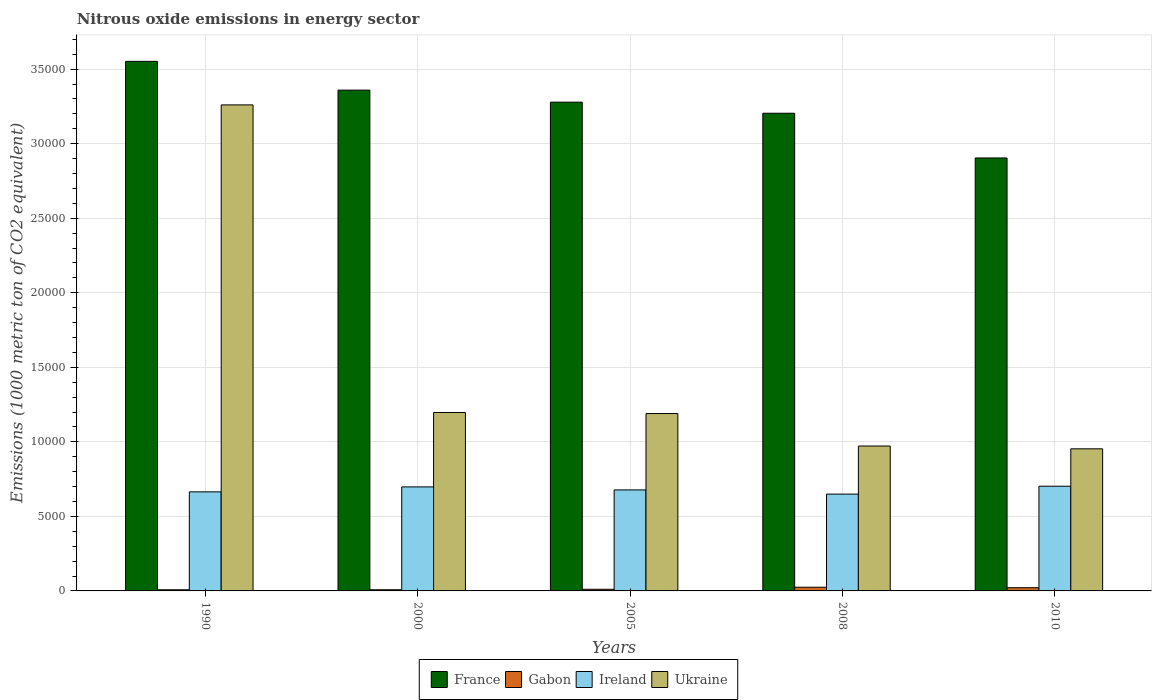How many groups of bars are there?
Give a very brief answer. 5. How many bars are there on the 5th tick from the right?
Provide a short and direct response. 4. In how many cases, is the number of bars for a given year not equal to the number of legend labels?
Give a very brief answer. 0. What is the amount of nitrous oxide emitted in Ireland in 2005?
Offer a terse response. 6774.5. Across all years, what is the maximum amount of nitrous oxide emitted in France?
Ensure brevity in your answer.  3.55e+04. Across all years, what is the minimum amount of nitrous oxide emitted in France?
Offer a terse response. 2.90e+04. In which year was the amount of nitrous oxide emitted in Gabon maximum?
Offer a very short reply. 2008. What is the total amount of nitrous oxide emitted in Ireland in the graph?
Your answer should be very brief. 3.39e+04. What is the difference between the amount of nitrous oxide emitted in Gabon in 2005 and that in 2010?
Your answer should be compact. -104.5. What is the difference between the amount of nitrous oxide emitted in Ukraine in 2000 and the amount of nitrous oxide emitted in Gabon in 1990?
Your answer should be very brief. 1.19e+04. What is the average amount of nitrous oxide emitted in Ireland per year?
Provide a short and direct response. 6782.7. In the year 2005, what is the difference between the amount of nitrous oxide emitted in Gabon and amount of nitrous oxide emitted in France?
Provide a succinct answer. -3.27e+04. In how many years, is the amount of nitrous oxide emitted in Gabon greater than 22000 1000 metric ton?
Offer a very short reply. 0. What is the ratio of the amount of nitrous oxide emitted in Ireland in 2000 to that in 2005?
Your response must be concise. 1.03. Is the amount of nitrous oxide emitted in Ireland in 2008 less than that in 2010?
Give a very brief answer. Yes. What is the difference between the highest and the second highest amount of nitrous oxide emitted in Ireland?
Your answer should be compact. 45.2. What is the difference between the highest and the lowest amount of nitrous oxide emitted in Ukraine?
Offer a terse response. 2.31e+04. What does the 2nd bar from the left in 2005 represents?
Keep it short and to the point. Gabon. What does the 3rd bar from the right in 2008 represents?
Keep it short and to the point. Gabon. Is it the case that in every year, the sum of the amount of nitrous oxide emitted in Gabon and amount of nitrous oxide emitted in France is greater than the amount of nitrous oxide emitted in Ukraine?
Provide a short and direct response. Yes. What is the difference between two consecutive major ticks on the Y-axis?
Ensure brevity in your answer.  5000. Are the values on the major ticks of Y-axis written in scientific E-notation?
Give a very brief answer. No. Does the graph contain grids?
Keep it short and to the point. Yes. How many legend labels are there?
Your answer should be very brief. 4. What is the title of the graph?
Your answer should be very brief. Nitrous oxide emissions in energy sector. Does "United States" appear as one of the legend labels in the graph?
Give a very brief answer. No. What is the label or title of the Y-axis?
Your response must be concise. Emissions (1000 metric ton of CO2 equivalent). What is the Emissions (1000 metric ton of CO2 equivalent) of France in 1990?
Ensure brevity in your answer.  3.55e+04. What is the Emissions (1000 metric ton of CO2 equivalent) of Gabon in 1990?
Make the answer very short. 77.4. What is the Emissions (1000 metric ton of CO2 equivalent) in Ireland in 1990?
Give a very brief answer. 6644.8. What is the Emissions (1000 metric ton of CO2 equivalent) of Ukraine in 1990?
Give a very brief answer. 3.26e+04. What is the Emissions (1000 metric ton of CO2 equivalent) in France in 2000?
Provide a short and direct response. 3.36e+04. What is the Emissions (1000 metric ton of CO2 equivalent) in Gabon in 2000?
Your response must be concise. 78.3. What is the Emissions (1000 metric ton of CO2 equivalent) in Ireland in 2000?
Your answer should be very brief. 6977.3. What is the Emissions (1000 metric ton of CO2 equivalent) in Ukraine in 2000?
Keep it short and to the point. 1.20e+04. What is the Emissions (1000 metric ton of CO2 equivalent) in France in 2005?
Ensure brevity in your answer.  3.28e+04. What is the Emissions (1000 metric ton of CO2 equivalent) in Gabon in 2005?
Your response must be concise. 110.8. What is the Emissions (1000 metric ton of CO2 equivalent) in Ireland in 2005?
Offer a very short reply. 6774.5. What is the Emissions (1000 metric ton of CO2 equivalent) of Ukraine in 2005?
Ensure brevity in your answer.  1.19e+04. What is the Emissions (1000 metric ton of CO2 equivalent) of France in 2008?
Ensure brevity in your answer.  3.20e+04. What is the Emissions (1000 metric ton of CO2 equivalent) in Gabon in 2008?
Provide a succinct answer. 248.2. What is the Emissions (1000 metric ton of CO2 equivalent) in Ireland in 2008?
Your answer should be very brief. 6494.4. What is the Emissions (1000 metric ton of CO2 equivalent) in Ukraine in 2008?
Ensure brevity in your answer.  9719.1. What is the Emissions (1000 metric ton of CO2 equivalent) in France in 2010?
Provide a succinct answer. 2.90e+04. What is the Emissions (1000 metric ton of CO2 equivalent) in Gabon in 2010?
Provide a short and direct response. 215.3. What is the Emissions (1000 metric ton of CO2 equivalent) in Ireland in 2010?
Your answer should be very brief. 7022.5. What is the Emissions (1000 metric ton of CO2 equivalent) in Ukraine in 2010?
Your answer should be very brief. 9531.4. Across all years, what is the maximum Emissions (1000 metric ton of CO2 equivalent) of France?
Make the answer very short. 3.55e+04. Across all years, what is the maximum Emissions (1000 metric ton of CO2 equivalent) in Gabon?
Offer a terse response. 248.2. Across all years, what is the maximum Emissions (1000 metric ton of CO2 equivalent) in Ireland?
Your answer should be compact. 7022.5. Across all years, what is the maximum Emissions (1000 metric ton of CO2 equivalent) of Ukraine?
Your response must be concise. 3.26e+04. Across all years, what is the minimum Emissions (1000 metric ton of CO2 equivalent) in France?
Your response must be concise. 2.90e+04. Across all years, what is the minimum Emissions (1000 metric ton of CO2 equivalent) of Gabon?
Your response must be concise. 77.4. Across all years, what is the minimum Emissions (1000 metric ton of CO2 equivalent) of Ireland?
Provide a succinct answer. 6494.4. Across all years, what is the minimum Emissions (1000 metric ton of CO2 equivalent) in Ukraine?
Provide a short and direct response. 9531.4. What is the total Emissions (1000 metric ton of CO2 equivalent) in France in the graph?
Your response must be concise. 1.63e+05. What is the total Emissions (1000 metric ton of CO2 equivalent) of Gabon in the graph?
Keep it short and to the point. 730. What is the total Emissions (1000 metric ton of CO2 equivalent) of Ireland in the graph?
Provide a short and direct response. 3.39e+04. What is the total Emissions (1000 metric ton of CO2 equivalent) of Ukraine in the graph?
Keep it short and to the point. 7.57e+04. What is the difference between the Emissions (1000 metric ton of CO2 equivalent) in France in 1990 and that in 2000?
Provide a short and direct response. 1930.3. What is the difference between the Emissions (1000 metric ton of CO2 equivalent) in Gabon in 1990 and that in 2000?
Offer a terse response. -0.9. What is the difference between the Emissions (1000 metric ton of CO2 equivalent) of Ireland in 1990 and that in 2000?
Your answer should be very brief. -332.5. What is the difference between the Emissions (1000 metric ton of CO2 equivalent) of Ukraine in 1990 and that in 2000?
Give a very brief answer. 2.06e+04. What is the difference between the Emissions (1000 metric ton of CO2 equivalent) in France in 1990 and that in 2005?
Provide a short and direct response. 2736.8. What is the difference between the Emissions (1000 metric ton of CO2 equivalent) of Gabon in 1990 and that in 2005?
Keep it short and to the point. -33.4. What is the difference between the Emissions (1000 metric ton of CO2 equivalent) of Ireland in 1990 and that in 2005?
Make the answer very short. -129.7. What is the difference between the Emissions (1000 metric ton of CO2 equivalent) of Ukraine in 1990 and that in 2005?
Your response must be concise. 2.07e+04. What is the difference between the Emissions (1000 metric ton of CO2 equivalent) of France in 1990 and that in 2008?
Your answer should be compact. 3480.3. What is the difference between the Emissions (1000 metric ton of CO2 equivalent) of Gabon in 1990 and that in 2008?
Offer a very short reply. -170.8. What is the difference between the Emissions (1000 metric ton of CO2 equivalent) in Ireland in 1990 and that in 2008?
Your response must be concise. 150.4. What is the difference between the Emissions (1000 metric ton of CO2 equivalent) of Ukraine in 1990 and that in 2008?
Provide a short and direct response. 2.29e+04. What is the difference between the Emissions (1000 metric ton of CO2 equivalent) in France in 1990 and that in 2010?
Provide a succinct answer. 6479.5. What is the difference between the Emissions (1000 metric ton of CO2 equivalent) in Gabon in 1990 and that in 2010?
Keep it short and to the point. -137.9. What is the difference between the Emissions (1000 metric ton of CO2 equivalent) in Ireland in 1990 and that in 2010?
Ensure brevity in your answer.  -377.7. What is the difference between the Emissions (1000 metric ton of CO2 equivalent) in Ukraine in 1990 and that in 2010?
Provide a short and direct response. 2.31e+04. What is the difference between the Emissions (1000 metric ton of CO2 equivalent) in France in 2000 and that in 2005?
Ensure brevity in your answer.  806.5. What is the difference between the Emissions (1000 metric ton of CO2 equivalent) of Gabon in 2000 and that in 2005?
Your answer should be very brief. -32.5. What is the difference between the Emissions (1000 metric ton of CO2 equivalent) in Ireland in 2000 and that in 2005?
Make the answer very short. 202.8. What is the difference between the Emissions (1000 metric ton of CO2 equivalent) of Ukraine in 2000 and that in 2005?
Provide a succinct answer. 70.4. What is the difference between the Emissions (1000 metric ton of CO2 equivalent) of France in 2000 and that in 2008?
Keep it short and to the point. 1550. What is the difference between the Emissions (1000 metric ton of CO2 equivalent) of Gabon in 2000 and that in 2008?
Offer a very short reply. -169.9. What is the difference between the Emissions (1000 metric ton of CO2 equivalent) in Ireland in 2000 and that in 2008?
Ensure brevity in your answer.  482.9. What is the difference between the Emissions (1000 metric ton of CO2 equivalent) of Ukraine in 2000 and that in 2008?
Provide a succinct answer. 2248.8. What is the difference between the Emissions (1000 metric ton of CO2 equivalent) of France in 2000 and that in 2010?
Provide a succinct answer. 4549.2. What is the difference between the Emissions (1000 metric ton of CO2 equivalent) in Gabon in 2000 and that in 2010?
Provide a short and direct response. -137. What is the difference between the Emissions (1000 metric ton of CO2 equivalent) of Ireland in 2000 and that in 2010?
Your answer should be very brief. -45.2. What is the difference between the Emissions (1000 metric ton of CO2 equivalent) in Ukraine in 2000 and that in 2010?
Your answer should be very brief. 2436.5. What is the difference between the Emissions (1000 metric ton of CO2 equivalent) of France in 2005 and that in 2008?
Provide a short and direct response. 743.5. What is the difference between the Emissions (1000 metric ton of CO2 equivalent) in Gabon in 2005 and that in 2008?
Ensure brevity in your answer.  -137.4. What is the difference between the Emissions (1000 metric ton of CO2 equivalent) in Ireland in 2005 and that in 2008?
Provide a short and direct response. 280.1. What is the difference between the Emissions (1000 metric ton of CO2 equivalent) of Ukraine in 2005 and that in 2008?
Your answer should be compact. 2178.4. What is the difference between the Emissions (1000 metric ton of CO2 equivalent) in France in 2005 and that in 2010?
Keep it short and to the point. 3742.7. What is the difference between the Emissions (1000 metric ton of CO2 equivalent) of Gabon in 2005 and that in 2010?
Provide a short and direct response. -104.5. What is the difference between the Emissions (1000 metric ton of CO2 equivalent) in Ireland in 2005 and that in 2010?
Provide a succinct answer. -248. What is the difference between the Emissions (1000 metric ton of CO2 equivalent) of Ukraine in 2005 and that in 2010?
Provide a succinct answer. 2366.1. What is the difference between the Emissions (1000 metric ton of CO2 equivalent) of France in 2008 and that in 2010?
Make the answer very short. 2999.2. What is the difference between the Emissions (1000 metric ton of CO2 equivalent) in Gabon in 2008 and that in 2010?
Make the answer very short. 32.9. What is the difference between the Emissions (1000 metric ton of CO2 equivalent) in Ireland in 2008 and that in 2010?
Your answer should be very brief. -528.1. What is the difference between the Emissions (1000 metric ton of CO2 equivalent) of Ukraine in 2008 and that in 2010?
Your answer should be compact. 187.7. What is the difference between the Emissions (1000 metric ton of CO2 equivalent) of France in 1990 and the Emissions (1000 metric ton of CO2 equivalent) of Gabon in 2000?
Ensure brevity in your answer.  3.54e+04. What is the difference between the Emissions (1000 metric ton of CO2 equivalent) of France in 1990 and the Emissions (1000 metric ton of CO2 equivalent) of Ireland in 2000?
Keep it short and to the point. 2.85e+04. What is the difference between the Emissions (1000 metric ton of CO2 equivalent) of France in 1990 and the Emissions (1000 metric ton of CO2 equivalent) of Ukraine in 2000?
Provide a succinct answer. 2.36e+04. What is the difference between the Emissions (1000 metric ton of CO2 equivalent) in Gabon in 1990 and the Emissions (1000 metric ton of CO2 equivalent) in Ireland in 2000?
Ensure brevity in your answer.  -6899.9. What is the difference between the Emissions (1000 metric ton of CO2 equivalent) of Gabon in 1990 and the Emissions (1000 metric ton of CO2 equivalent) of Ukraine in 2000?
Your answer should be very brief. -1.19e+04. What is the difference between the Emissions (1000 metric ton of CO2 equivalent) of Ireland in 1990 and the Emissions (1000 metric ton of CO2 equivalent) of Ukraine in 2000?
Give a very brief answer. -5323.1. What is the difference between the Emissions (1000 metric ton of CO2 equivalent) of France in 1990 and the Emissions (1000 metric ton of CO2 equivalent) of Gabon in 2005?
Keep it short and to the point. 3.54e+04. What is the difference between the Emissions (1000 metric ton of CO2 equivalent) in France in 1990 and the Emissions (1000 metric ton of CO2 equivalent) in Ireland in 2005?
Your answer should be very brief. 2.87e+04. What is the difference between the Emissions (1000 metric ton of CO2 equivalent) in France in 1990 and the Emissions (1000 metric ton of CO2 equivalent) in Ukraine in 2005?
Provide a short and direct response. 2.36e+04. What is the difference between the Emissions (1000 metric ton of CO2 equivalent) in Gabon in 1990 and the Emissions (1000 metric ton of CO2 equivalent) in Ireland in 2005?
Make the answer very short. -6697.1. What is the difference between the Emissions (1000 metric ton of CO2 equivalent) of Gabon in 1990 and the Emissions (1000 metric ton of CO2 equivalent) of Ukraine in 2005?
Offer a terse response. -1.18e+04. What is the difference between the Emissions (1000 metric ton of CO2 equivalent) in Ireland in 1990 and the Emissions (1000 metric ton of CO2 equivalent) in Ukraine in 2005?
Offer a very short reply. -5252.7. What is the difference between the Emissions (1000 metric ton of CO2 equivalent) of France in 1990 and the Emissions (1000 metric ton of CO2 equivalent) of Gabon in 2008?
Your response must be concise. 3.53e+04. What is the difference between the Emissions (1000 metric ton of CO2 equivalent) in France in 1990 and the Emissions (1000 metric ton of CO2 equivalent) in Ireland in 2008?
Ensure brevity in your answer.  2.90e+04. What is the difference between the Emissions (1000 metric ton of CO2 equivalent) in France in 1990 and the Emissions (1000 metric ton of CO2 equivalent) in Ukraine in 2008?
Offer a very short reply. 2.58e+04. What is the difference between the Emissions (1000 metric ton of CO2 equivalent) of Gabon in 1990 and the Emissions (1000 metric ton of CO2 equivalent) of Ireland in 2008?
Keep it short and to the point. -6417. What is the difference between the Emissions (1000 metric ton of CO2 equivalent) in Gabon in 1990 and the Emissions (1000 metric ton of CO2 equivalent) in Ukraine in 2008?
Your answer should be very brief. -9641.7. What is the difference between the Emissions (1000 metric ton of CO2 equivalent) of Ireland in 1990 and the Emissions (1000 metric ton of CO2 equivalent) of Ukraine in 2008?
Keep it short and to the point. -3074.3. What is the difference between the Emissions (1000 metric ton of CO2 equivalent) of France in 1990 and the Emissions (1000 metric ton of CO2 equivalent) of Gabon in 2010?
Make the answer very short. 3.53e+04. What is the difference between the Emissions (1000 metric ton of CO2 equivalent) in France in 1990 and the Emissions (1000 metric ton of CO2 equivalent) in Ireland in 2010?
Your answer should be compact. 2.85e+04. What is the difference between the Emissions (1000 metric ton of CO2 equivalent) of France in 1990 and the Emissions (1000 metric ton of CO2 equivalent) of Ukraine in 2010?
Offer a very short reply. 2.60e+04. What is the difference between the Emissions (1000 metric ton of CO2 equivalent) of Gabon in 1990 and the Emissions (1000 metric ton of CO2 equivalent) of Ireland in 2010?
Provide a succinct answer. -6945.1. What is the difference between the Emissions (1000 metric ton of CO2 equivalent) of Gabon in 1990 and the Emissions (1000 metric ton of CO2 equivalent) of Ukraine in 2010?
Your answer should be very brief. -9454. What is the difference between the Emissions (1000 metric ton of CO2 equivalent) of Ireland in 1990 and the Emissions (1000 metric ton of CO2 equivalent) of Ukraine in 2010?
Offer a terse response. -2886.6. What is the difference between the Emissions (1000 metric ton of CO2 equivalent) of France in 2000 and the Emissions (1000 metric ton of CO2 equivalent) of Gabon in 2005?
Offer a terse response. 3.35e+04. What is the difference between the Emissions (1000 metric ton of CO2 equivalent) in France in 2000 and the Emissions (1000 metric ton of CO2 equivalent) in Ireland in 2005?
Offer a terse response. 2.68e+04. What is the difference between the Emissions (1000 metric ton of CO2 equivalent) of France in 2000 and the Emissions (1000 metric ton of CO2 equivalent) of Ukraine in 2005?
Your response must be concise. 2.17e+04. What is the difference between the Emissions (1000 metric ton of CO2 equivalent) of Gabon in 2000 and the Emissions (1000 metric ton of CO2 equivalent) of Ireland in 2005?
Your answer should be very brief. -6696.2. What is the difference between the Emissions (1000 metric ton of CO2 equivalent) in Gabon in 2000 and the Emissions (1000 metric ton of CO2 equivalent) in Ukraine in 2005?
Your answer should be compact. -1.18e+04. What is the difference between the Emissions (1000 metric ton of CO2 equivalent) in Ireland in 2000 and the Emissions (1000 metric ton of CO2 equivalent) in Ukraine in 2005?
Make the answer very short. -4920.2. What is the difference between the Emissions (1000 metric ton of CO2 equivalent) of France in 2000 and the Emissions (1000 metric ton of CO2 equivalent) of Gabon in 2008?
Ensure brevity in your answer.  3.33e+04. What is the difference between the Emissions (1000 metric ton of CO2 equivalent) in France in 2000 and the Emissions (1000 metric ton of CO2 equivalent) in Ireland in 2008?
Ensure brevity in your answer.  2.71e+04. What is the difference between the Emissions (1000 metric ton of CO2 equivalent) in France in 2000 and the Emissions (1000 metric ton of CO2 equivalent) in Ukraine in 2008?
Your answer should be compact. 2.39e+04. What is the difference between the Emissions (1000 metric ton of CO2 equivalent) in Gabon in 2000 and the Emissions (1000 metric ton of CO2 equivalent) in Ireland in 2008?
Your answer should be compact. -6416.1. What is the difference between the Emissions (1000 metric ton of CO2 equivalent) in Gabon in 2000 and the Emissions (1000 metric ton of CO2 equivalent) in Ukraine in 2008?
Offer a very short reply. -9640.8. What is the difference between the Emissions (1000 metric ton of CO2 equivalent) of Ireland in 2000 and the Emissions (1000 metric ton of CO2 equivalent) of Ukraine in 2008?
Offer a very short reply. -2741.8. What is the difference between the Emissions (1000 metric ton of CO2 equivalent) of France in 2000 and the Emissions (1000 metric ton of CO2 equivalent) of Gabon in 2010?
Make the answer very short. 3.34e+04. What is the difference between the Emissions (1000 metric ton of CO2 equivalent) in France in 2000 and the Emissions (1000 metric ton of CO2 equivalent) in Ireland in 2010?
Your answer should be very brief. 2.66e+04. What is the difference between the Emissions (1000 metric ton of CO2 equivalent) in France in 2000 and the Emissions (1000 metric ton of CO2 equivalent) in Ukraine in 2010?
Provide a succinct answer. 2.41e+04. What is the difference between the Emissions (1000 metric ton of CO2 equivalent) of Gabon in 2000 and the Emissions (1000 metric ton of CO2 equivalent) of Ireland in 2010?
Offer a terse response. -6944.2. What is the difference between the Emissions (1000 metric ton of CO2 equivalent) in Gabon in 2000 and the Emissions (1000 metric ton of CO2 equivalent) in Ukraine in 2010?
Make the answer very short. -9453.1. What is the difference between the Emissions (1000 metric ton of CO2 equivalent) of Ireland in 2000 and the Emissions (1000 metric ton of CO2 equivalent) of Ukraine in 2010?
Give a very brief answer. -2554.1. What is the difference between the Emissions (1000 metric ton of CO2 equivalent) in France in 2005 and the Emissions (1000 metric ton of CO2 equivalent) in Gabon in 2008?
Offer a terse response. 3.25e+04. What is the difference between the Emissions (1000 metric ton of CO2 equivalent) in France in 2005 and the Emissions (1000 metric ton of CO2 equivalent) in Ireland in 2008?
Keep it short and to the point. 2.63e+04. What is the difference between the Emissions (1000 metric ton of CO2 equivalent) in France in 2005 and the Emissions (1000 metric ton of CO2 equivalent) in Ukraine in 2008?
Provide a short and direct response. 2.31e+04. What is the difference between the Emissions (1000 metric ton of CO2 equivalent) of Gabon in 2005 and the Emissions (1000 metric ton of CO2 equivalent) of Ireland in 2008?
Offer a terse response. -6383.6. What is the difference between the Emissions (1000 metric ton of CO2 equivalent) of Gabon in 2005 and the Emissions (1000 metric ton of CO2 equivalent) of Ukraine in 2008?
Give a very brief answer. -9608.3. What is the difference between the Emissions (1000 metric ton of CO2 equivalent) of Ireland in 2005 and the Emissions (1000 metric ton of CO2 equivalent) of Ukraine in 2008?
Your answer should be very brief. -2944.6. What is the difference between the Emissions (1000 metric ton of CO2 equivalent) in France in 2005 and the Emissions (1000 metric ton of CO2 equivalent) in Gabon in 2010?
Offer a terse response. 3.26e+04. What is the difference between the Emissions (1000 metric ton of CO2 equivalent) in France in 2005 and the Emissions (1000 metric ton of CO2 equivalent) in Ireland in 2010?
Make the answer very short. 2.58e+04. What is the difference between the Emissions (1000 metric ton of CO2 equivalent) of France in 2005 and the Emissions (1000 metric ton of CO2 equivalent) of Ukraine in 2010?
Give a very brief answer. 2.33e+04. What is the difference between the Emissions (1000 metric ton of CO2 equivalent) of Gabon in 2005 and the Emissions (1000 metric ton of CO2 equivalent) of Ireland in 2010?
Your answer should be very brief. -6911.7. What is the difference between the Emissions (1000 metric ton of CO2 equivalent) of Gabon in 2005 and the Emissions (1000 metric ton of CO2 equivalent) of Ukraine in 2010?
Ensure brevity in your answer.  -9420.6. What is the difference between the Emissions (1000 metric ton of CO2 equivalent) in Ireland in 2005 and the Emissions (1000 metric ton of CO2 equivalent) in Ukraine in 2010?
Offer a terse response. -2756.9. What is the difference between the Emissions (1000 metric ton of CO2 equivalent) of France in 2008 and the Emissions (1000 metric ton of CO2 equivalent) of Gabon in 2010?
Make the answer very short. 3.18e+04. What is the difference between the Emissions (1000 metric ton of CO2 equivalent) in France in 2008 and the Emissions (1000 metric ton of CO2 equivalent) in Ireland in 2010?
Ensure brevity in your answer.  2.50e+04. What is the difference between the Emissions (1000 metric ton of CO2 equivalent) of France in 2008 and the Emissions (1000 metric ton of CO2 equivalent) of Ukraine in 2010?
Your answer should be compact. 2.25e+04. What is the difference between the Emissions (1000 metric ton of CO2 equivalent) of Gabon in 2008 and the Emissions (1000 metric ton of CO2 equivalent) of Ireland in 2010?
Provide a succinct answer. -6774.3. What is the difference between the Emissions (1000 metric ton of CO2 equivalent) of Gabon in 2008 and the Emissions (1000 metric ton of CO2 equivalent) of Ukraine in 2010?
Your response must be concise. -9283.2. What is the difference between the Emissions (1000 metric ton of CO2 equivalent) of Ireland in 2008 and the Emissions (1000 metric ton of CO2 equivalent) of Ukraine in 2010?
Your answer should be compact. -3037. What is the average Emissions (1000 metric ton of CO2 equivalent) of France per year?
Your answer should be very brief. 3.26e+04. What is the average Emissions (1000 metric ton of CO2 equivalent) in Gabon per year?
Give a very brief answer. 146. What is the average Emissions (1000 metric ton of CO2 equivalent) in Ireland per year?
Your response must be concise. 6782.7. What is the average Emissions (1000 metric ton of CO2 equivalent) in Ukraine per year?
Offer a very short reply. 1.51e+04. In the year 1990, what is the difference between the Emissions (1000 metric ton of CO2 equivalent) in France and Emissions (1000 metric ton of CO2 equivalent) in Gabon?
Make the answer very short. 3.54e+04. In the year 1990, what is the difference between the Emissions (1000 metric ton of CO2 equivalent) of France and Emissions (1000 metric ton of CO2 equivalent) of Ireland?
Ensure brevity in your answer.  2.89e+04. In the year 1990, what is the difference between the Emissions (1000 metric ton of CO2 equivalent) in France and Emissions (1000 metric ton of CO2 equivalent) in Ukraine?
Your answer should be very brief. 2920.6. In the year 1990, what is the difference between the Emissions (1000 metric ton of CO2 equivalent) of Gabon and Emissions (1000 metric ton of CO2 equivalent) of Ireland?
Offer a terse response. -6567.4. In the year 1990, what is the difference between the Emissions (1000 metric ton of CO2 equivalent) in Gabon and Emissions (1000 metric ton of CO2 equivalent) in Ukraine?
Give a very brief answer. -3.25e+04. In the year 1990, what is the difference between the Emissions (1000 metric ton of CO2 equivalent) of Ireland and Emissions (1000 metric ton of CO2 equivalent) of Ukraine?
Your answer should be compact. -2.60e+04. In the year 2000, what is the difference between the Emissions (1000 metric ton of CO2 equivalent) of France and Emissions (1000 metric ton of CO2 equivalent) of Gabon?
Offer a very short reply. 3.35e+04. In the year 2000, what is the difference between the Emissions (1000 metric ton of CO2 equivalent) of France and Emissions (1000 metric ton of CO2 equivalent) of Ireland?
Offer a very short reply. 2.66e+04. In the year 2000, what is the difference between the Emissions (1000 metric ton of CO2 equivalent) in France and Emissions (1000 metric ton of CO2 equivalent) in Ukraine?
Provide a succinct answer. 2.16e+04. In the year 2000, what is the difference between the Emissions (1000 metric ton of CO2 equivalent) of Gabon and Emissions (1000 metric ton of CO2 equivalent) of Ireland?
Give a very brief answer. -6899. In the year 2000, what is the difference between the Emissions (1000 metric ton of CO2 equivalent) in Gabon and Emissions (1000 metric ton of CO2 equivalent) in Ukraine?
Your response must be concise. -1.19e+04. In the year 2000, what is the difference between the Emissions (1000 metric ton of CO2 equivalent) of Ireland and Emissions (1000 metric ton of CO2 equivalent) of Ukraine?
Offer a very short reply. -4990.6. In the year 2005, what is the difference between the Emissions (1000 metric ton of CO2 equivalent) in France and Emissions (1000 metric ton of CO2 equivalent) in Gabon?
Give a very brief answer. 3.27e+04. In the year 2005, what is the difference between the Emissions (1000 metric ton of CO2 equivalent) of France and Emissions (1000 metric ton of CO2 equivalent) of Ireland?
Provide a short and direct response. 2.60e+04. In the year 2005, what is the difference between the Emissions (1000 metric ton of CO2 equivalent) of France and Emissions (1000 metric ton of CO2 equivalent) of Ukraine?
Give a very brief answer. 2.09e+04. In the year 2005, what is the difference between the Emissions (1000 metric ton of CO2 equivalent) of Gabon and Emissions (1000 metric ton of CO2 equivalent) of Ireland?
Offer a terse response. -6663.7. In the year 2005, what is the difference between the Emissions (1000 metric ton of CO2 equivalent) of Gabon and Emissions (1000 metric ton of CO2 equivalent) of Ukraine?
Your answer should be very brief. -1.18e+04. In the year 2005, what is the difference between the Emissions (1000 metric ton of CO2 equivalent) of Ireland and Emissions (1000 metric ton of CO2 equivalent) of Ukraine?
Make the answer very short. -5123. In the year 2008, what is the difference between the Emissions (1000 metric ton of CO2 equivalent) of France and Emissions (1000 metric ton of CO2 equivalent) of Gabon?
Give a very brief answer. 3.18e+04. In the year 2008, what is the difference between the Emissions (1000 metric ton of CO2 equivalent) in France and Emissions (1000 metric ton of CO2 equivalent) in Ireland?
Make the answer very short. 2.55e+04. In the year 2008, what is the difference between the Emissions (1000 metric ton of CO2 equivalent) in France and Emissions (1000 metric ton of CO2 equivalent) in Ukraine?
Offer a very short reply. 2.23e+04. In the year 2008, what is the difference between the Emissions (1000 metric ton of CO2 equivalent) in Gabon and Emissions (1000 metric ton of CO2 equivalent) in Ireland?
Your answer should be very brief. -6246.2. In the year 2008, what is the difference between the Emissions (1000 metric ton of CO2 equivalent) in Gabon and Emissions (1000 metric ton of CO2 equivalent) in Ukraine?
Your answer should be compact. -9470.9. In the year 2008, what is the difference between the Emissions (1000 metric ton of CO2 equivalent) in Ireland and Emissions (1000 metric ton of CO2 equivalent) in Ukraine?
Offer a terse response. -3224.7. In the year 2010, what is the difference between the Emissions (1000 metric ton of CO2 equivalent) of France and Emissions (1000 metric ton of CO2 equivalent) of Gabon?
Provide a short and direct response. 2.88e+04. In the year 2010, what is the difference between the Emissions (1000 metric ton of CO2 equivalent) in France and Emissions (1000 metric ton of CO2 equivalent) in Ireland?
Your answer should be compact. 2.20e+04. In the year 2010, what is the difference between the Emissions (1000 metric ton of CO2 equivalent) of France and Emissions (1000 metric ton of CO2 equivalent) of Ukraine?
Make the answer very short. 1.95e+04. In the year 2010, what is the difference between the Emissions (1000 metric ton of CO2 equivalent) of Gabon and Emissions (1000 metric ton of CO2 equivalent) of Ireland?
Provide a succinct answer. -6807.2. In the year 2010, what is the difference between the Emissions (1000 metric ton of CO2 equivalent) of Gabon and Emissions (1000 metric ton of CO2 equivalent) of Ukraine?
Give a very brief answer. -9316.1. In the year 2010, what is the difference between the Emissions (1000 metric ton of CO2 equivalent) in Ireland and Emissions (1000 metric ton of CO2 equivalent) in Ukraine?
Give a very brief answer. -2508.9. What is the ratio of the Emissions (1000 metric ton of CO2 equivalent) in France in 1990 to that in 2000?
Give a very brief answer. 1.06. What is the ratio of the Emissions (1000 metric ton of CO2 equivalent) in Ireland in 1990 to that in 2000?
Ensure brevity in your answer.  0.95. What is the ratio of the Emissions (1000 metric ton of CO2 equivalent) in Ukraine in 1990 to that in 2000?
Your answer should be very brief. 2.72. What is the ratio of the Emissions (1000 metric ton of CO2 equivalent) in France in 1990 to that in 2005?
Provide a succinct answer. 1.08. What is the ratio of the Emissions (1000 metric ton of CO2 equivalent) in Gabon in 1990 to that in 2005?
Give a very brief answer. 0.7. What is the ratio of the Emissions (1000 metric ton of CO2 equivalent) of Ireland in 1990 to that in 2005?
Your response must be concise. 0.98. What is the ratio of the Emissions (1000 metric ton of CO2 equivalent) of Ukraine in 1990 to that in 2005?
Your answer should be very brief. 2.74. What is the ratio of the Emissions (1000 metric ton of CO2 equivalent) in France in 1990 to that in 2008?
Make the answer very short. 1.11. What is the ratio of the Emissions (1000 metric ton of CO2 equivalent) in Gabon in 1990 to that in 2008?
Ensure brevity in your answer.  0.31. What is the ratio of the Emissions (1000 metric ton of CO2 equivalent) in Ireland in 1990 to that in 2008?
Keep it short and to the point. 1.02. What is the ratio of the Emissions (1000 metric ton of CO2 equivalent) in Ukraine in 1990 to that in 2008?
Provide a short and direct response. 3.35. What is the ratio of the Emissions (1000 metric ton of CO2 equivalent) in France in 1990 to that in 2010?
Your answer should be very brief. 1.22. What is the ratio of the Emissions (1000 metric ton of CO2 equivalent) in Gabon in 1990 to that in 2010?
Ensure brevity in your answer.  0.36. What is the ratio of the Emissions (1000 metric ton of CO2 equivalent) in Ireland in 1990 to that in 2010?
Give a very brief answer. 0.95. What is the ratio of the Emissions (1000 metric ton of CO2 equivalent) in Ukraine in 1990 to that in 2010?
Ensure brevity in your answer.  3.42. What is the ratio of the Emissions (1000 metric ton of CO2 equivalent) in France in 2000 to that in 2005?
Your response must be concise. 1.02. What is the ratio of the Emissions (1000 metric ton of CO2 equivalent) of Gabon in 2000 to that in 2005?
Offer a very short reply. 0.71. What is the ratio of the Emissions (1000 metric ton of CO2 equivalent) of Ireland in 2000 to that in 2005?
Your response must be concise. 1.03. What is the ratio of the Emissions (1000 metric ton of CO2 equivalent) of Ukraine in 2000 to that in 2005?
Offer a terse response. 1.01. What is the ratio of the Emissions (1000 metric ton of CO2 equivalent) of France in 2000 to that in 2008?
Make the answer very short. 1.05. What is the ratio of the Emissions (1000 metric ton of CO2 equivalent) in Gabon in 2000 to that in 2008?
Provide a short and direct response. 0.32. What is the ratio of the Emissions (1000 metric ton of CO2 equivalent) in Ireland in 2000 to that in 2008?
Your answer should be very brief. 1.07. What is the ratio of the Emissions (1000 metric ton of CO2 equivalent) of Ukraine in 2000 to that in 2008?
Offer a very short reply. 1.23. What is the ratio of the Emissions (1000 metric ton of CO2 equivalent) in France in 2000 to that in 2010?
Give a very brief answer. 1.16. What is the ratio of the Emissions (1000 metric ton of CO2 equivalent) of Gabon in 2000 to that in 2010?
Keep it short and to the point. 0.36. What is the ratio of the Emissions (1000 metric ton of CO2 equivalent) of Ireland in 2000 to that in 2010?
Give a very brief answer. 0.99. What is the ratio of the Emissions (1000 metric ton of CO2 equivalent) in Ukraine in 2000 to that in 2010?
Offer a very short reply. 1.26. What is the ratio of the Emissions (1000 metric ton of CO2 equivalent) of France in 2005 to that in 2008?
Your response must be concise. 1.02. What is the ratio of the Emissions (1000 metric ton of CO2 equivalent) of Gabon in 2005 to that in 2008?
Make the answer very short. 0.45. What is the ratio of the Emissions (1000 metric ton of CO2 equivalent) in Ireland in 2005 to that in 2008?
Ensure brevity in your answer.  1.04. What is the ratio of the Emissions (1000 metric ton of CO2 equivalent) of Ukraine in 2005 to that in 2008?
Offer a terse response. 1.22. What is the ratio of the Emissions (1000 metric ton of CO2 equivalent) of France in 2005 to that in 2010?
Provide a succinct answer. 1.13. What is the ratio of the Emissions (1000 metric ton of CO2 equivalent) in Gabon in 2005 to that in 2010?
Offer a very short reply. 0.51. What is the ratio of the Emissions (1000 metric ton of CO2 equivalent) in Ireland in 2005 to that in 2010?
Your answer should be very brief. 0.96. What is the ratio of the Emissions (1000 metric ton of CO2 equivalent) of Ukraine in 2005 to that in 2010?
Ensure brevity in your answer.  1.25. What is the ratio of the Emissions (1000 metric ton of CO2 equivalent) in France in 2008 to that in 2010?
Offer a very short reply. 1.1. What is the ratio of the Emissions (1000 metric ton of CO2 equivalent) of Gabon in 2008 to that in 2010?
Offer a very short reply. 1.15. What is the ratio of the Emissions (1000 metric ton of CO2 equivalent) in Ireland in 2008 to that in 2010?
Offer a very short reply. 0.92. What is the ratio of the Emissions (1000 metric ton of CO2 equivalent) of Ukraine in 2008 to that in 2010?
Provide a short and direct response. 1.02. What is the difference between the highest and the second highest Emissions (1000 metric ton of CO2 equivalent) in France?
Your response must be concise. 1930.3. What is the difference between the highest and the second highest Emissions (1000 metric ton of CO2 equivalent) of Gabon?
Offer a very short reply. 32.9. What is the difference between the highest and the second highest Emissions (1000 metric ton of CO2 equivalent) in Ireland?
Your response must be concise. 45.2. What is the difference between the highest and the second highest Emissions (1000 metric ton of CO2 equivalent) of Ukraine?
Your answer should be compact. 2.06e+04. What is the difference between the highest and the lowest Emissions (1000 metric ton of CO2 equivalent) in France?
Your answer should be compact. 6479.5. What is the difference between the highest and the lowest Emissions (1000 metric ton of CO2 equivalent) of Gabon?
Give a very brief answer. 170.8. What is the difference between the highest and the lowest Emissions (1000 metric ton of CO2 equivalent) of Ireland?
Make the answer very short. 528.1. What is the difference between the highest and the lowest Emissions (1000 metric ton of CO2 equivalent) of Ukraine?
Keep it short and to the point. 2.31e+04. 